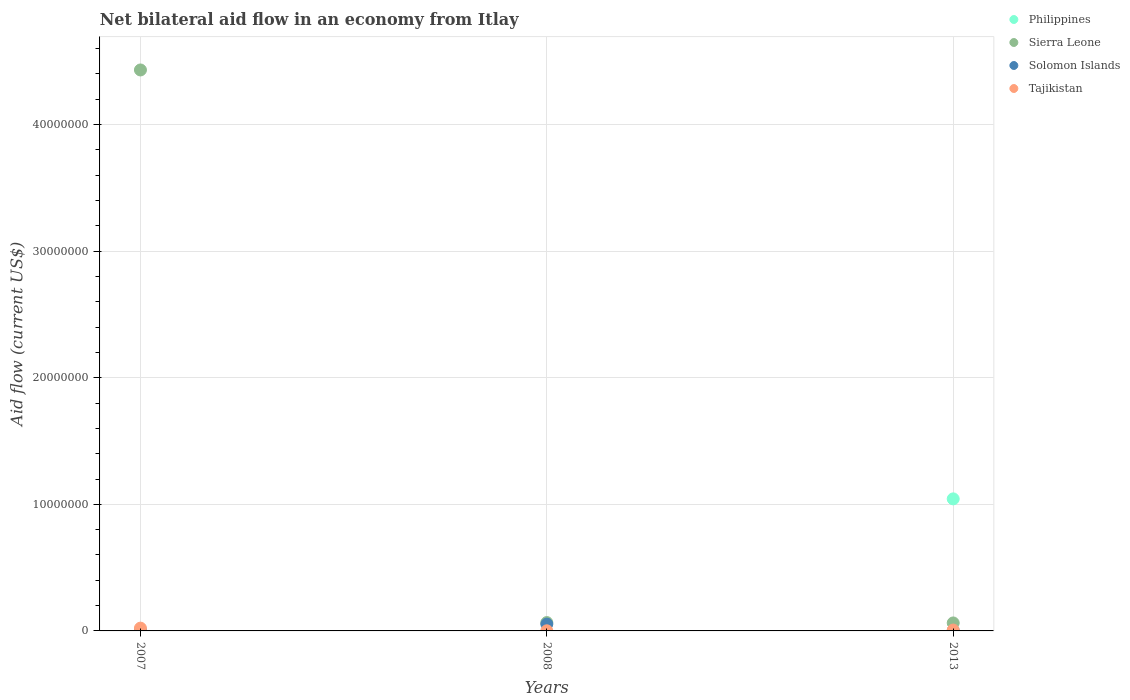How many different coloured dotlines are there?
Make the answer very short. 4. What is the net bilateral aid flow in Tajikistan in 2008?
Offer a very short reply. 10000. What is the total net bilateral aid flow in Philippines in the graph?
Your response must be concise. 1.04e+07. What is the difference between the net bilateral aid flow in Solomon Islands in 2008 and that in 2013?
Give a very brief answer. 5.20e+05. What is the difference between the net bilateral aid flow in Tajikistan in 2008 and the net bilateral aid flow in Sierra Leone in 2007?
Provide a succinct answer. -4.43e+07. What is the average net bilateral aid flow in Philippines per year?
Give a very brief answer. 3.48e+06. In the year 2007, what is the difference between the net bilateral aid flow in Sierra Leone and net bilateral aid flow in Tajikistan?
Provide a short and direct response. 4.41e+07. In how many years, is the net bilateral aid flow in Philippines greater than 34000000 US$?
Offer a very short reply. 0. What is the ratio of the net bilateral aid flow in Solomon Islands in 2007 to that in 2008?
Give a very brief answer. 0.09. Is the net bilateral aid flow in Tajikistan in 2007 less than that in 2013?
Your response must be concise. No. What is the difference between the highest and the lowest net bilateral aid flow in Solomon Islands?
Your answer should be very brief. 5.20e+05. In how many years, is the net bilateral aid flow in Solomon Islands greater than the average net bilateral aid flow in Solomon Islands taken over all years?
Provide a short and direct response. 1. Is it the case that in every year, the sum of the net bilateral aid flow in Philippines and net bilateral aid flow in Tajikistan  is greater than the net bilateral aid flow in Solomon Islands?
Ensure brevity in your answer.  No. Does the net bilateral aid flow in Tajikistan monotonically increase over the years?
Provide a succinct answer. No. Is the net bilateral aid flow in Sierra Leone strictly greater than the net bilateral aid flow in Philippines over the years?
Ensure brevity in your answer.  No. How many dotlines are there?
Your response must be concise. 4. What is the difference between two consecutive major ticks on the Y-axis?
Provide a succinct answer. 1.00e+07. Does the graph contain any zero values?
Offer a very short reply. Yes. How many legend labels are there?
Your answer should be very brief. 4. How are the legend labels stacked?
Ensure brevity in your answer.  Vertical. What is the title of the graph?
Provide a succinct answer. Net bilateral aid flow in an economy from Itlay. What is the label or title of the X-axis?
Offer a very short reply. Years. What is the Aid flow (current US$) in Philippines in 2007?
Your answer should be very brief. 0. What is the Aid flow (current US$) in Sierra Leone in 2007?
Keep it short and to the point. 4.43e+07. What is the Aid flow (current US$) of Solomon Islands in 2007?
Keep it short and to the point. 5.00e+04. What is the Aid flow (current US$) in Solomon Islands in 2008?
Make the answer very short. 5.40e+05. What is the Aid flow (current US$) of Tajikistan in 2008?
Offer a terse response. 10000. What is the Aid flow (current US$) of Philippines in 2013?
Your answer should be very brief. 1.04e+07. What is the Aid flow (current US$) of Sierra Leone in 2013?
Your answer should be very brief. 6.30e+05. What is the Aid flow (current US$) in Solomon Islands in 2013?
Your response must be concise. 2.00e+04. Across all years, what is the maximum Aid flow (current US$) of Philippines?
Your answer should be very brief. 1.04e+07. Across all years, what is the maximum Aid flow (current US$) of Sierra Leone?
Offer a terse response. 4.43e+07. Across all years, what is the maximum Aid flow (current US$) in Solomon Islands?
Provide a short and direct response. 5.40e+05. Across all years, what is the minimum Aid flow (current US$) of Philippines?
Ensure brevity in your answer.  0. Across all years, what is the minimum Aid flow (current US$) of Sierra Leone?
Ensure brevity in your answer.  6.30e+05. Across all years, what is the minimum Aid flow (current US$) in Solomon Islands?
Provide a succinct answer. 2.00e+04. What is the total Aid flow (current US$) in Philippines in the graph?
Your response must be concise. 1.04e+07. What is the total Aid flow (current US$) in Sierra Leone in the graph?
Your response must be concise. 4.56e+07. What is the total Aid flow (current US$) in Tajikistan in the graph?
Ensure brevity in your answer.  3.00e+05. What is the difference between the Aid flow (current US$) in Sierra Leone in 2007 and that in 2008?
Offer a terse response. 4.36e+07. What is the difference between the Aid flow (current US$) of Solomon Islands in 2007 and that in 2008?
Keep it short and to the point. -4.90e+05. What is the difference between the Aid flow (current US$) of Sierra Leone in 2007 and that in 2013?
Keep it short and to the point. 4.37e+07. What is the difference between the Aid flow (current US$) in Solomon Islands in 2007 and that in 2013?
Offer a very short reply. 3.00e+04. What is the difference between the Aid flow (current US$) in Sierra Leone in 2008 and that in 2013?
Ensure brevity in your answer.  3.00e+04. What is the difference between the Aid flow (current US$) in Solomon Islands in 2008 and that in 2013?
Provide a short and direct response. 5.20e+05. What is the difference between the Aid flow (current US$) of Tajikistan in 2008 and that in 2013?
Offer a very short reply. -6.00e+04. What is the difference between the Aid flow (current US$) of Sierra Leone in 2007 and the Aid flow (current US$) of Solomon Islands in 2008?
Provide a short and direct response. 4.38e+07. What is the difference between the Aid flow (current US$) in Sierra Leone in 2007 and the Aid flow (current US$) in Tajikistan in 2008?
Make the answer very short. 4.43e+07. What is the difference between the Aid flow (current US$) of Solomon Islands in 2007 and the Aid flow (current US$) of Tajikistan in 2008?
Offer a very short reply. 4.00e+04. What is the difference between the Aid flow (current US$) of Sierra Leone in 2007 and the Aid flow (current US$) of Solomon Islands in 2013?
Provide a short and direct response. 4.43e+07. What is the difference between the Aid flow (current US$) of Sierra Leone in 2007 and the Aid flow (current US$) of Tajikistan in 2013?
Ensure brevity in your answer.  4.42e+07. What is the difference between the Aid flow (current US$) of Solomon Islands in 2007 and the Aid flow (current US$) of Tajikistan in 2013?
Ensure brevity in your answer.  -2.00e+04. What is the difference between the Aid flow (current US$) in Sierra Leone in 2008 and the Aid flow (current US$) in Solomon Islands in 2013?
Make the answer very short. 6.40e+05. What is the difference between the Aid flow (current US$) of Sierra Leone in 2008 and the Aid flow (current US$) of Tajikistan in 2013?
Offer a terse response. 5.90e+05. What is the average Aid flow (current US$) of Philippines per year?
Give a very brief answer. 3.48e+06. What is the average Aid flow (current US$) of Sierra Leone per year?
Make the answer very short. 1.52e+07. What is the average Aid flow (current US$) of Solomon Islands per year?
Offer a terse response. 2.03e+05. In the year 2007, what is the difference between the Aid flow (current US$) in Sierra Leone and Aid flow (current US$) in Solomon Islands?
Keep it short and to the point. 4.43e+07. In the year 2007, what is the difference between the Aid flow (current US$) in Sierra Leone and Aid flow (current US$) in Tajikistan?
Provide a succinct answer. 4.41e+07. In the year 2007, what is the difference between the Aid flow (current US$) of Solomon Islands and Aid flow (current US$) of Tajikistan?
Your answer should be compact. -1.70e+05. In the year 2008, what is the difference between the Aid flow (current US$) in Sierra Leone and Aid flow (current US$) in Tajikistan?
Keep it short and to the point. 6.50e+05. In the year 2008, what is the difference between the Aid flow (current US$) in Solomon Islands and Aid flow (current US$) in Tajikistan?
Provide a short and direct response. 5.30e+05. In the year 2013, what is the difference between the Aid flow (current US$) of Philippines and Aid flow (current US$) of Sierra Leone?
Offer a very short reply. 9.80e+06. In the year 2013, what is the difference between the Aid flow (current US$) of Philippines and Aid flow (current US$) of Solomon Islands?
Offer a terse response. 1.04e+07. In the year 2013, what is the difference between the Aid flow (current US$) in Philippines and Aid flow (current US$) in Tajikistan?
Offer a terse response. 1.04e+07. In the year 2013, what is the difference between the Aid flow (current US$) in Sierra Leone and Aid flow (current US$) in Solomon Islands?
Offer a very short reply. 6.10e+05. In the year 2013, what is the difference between the Aid flow (current US$) of Sierra Leone and Aid flow (current US$) of Tajikistan?
Provide a short and direct response. 5.60e+05. What is the ratio of the Aid flow (current US$) in Sierra Leone in 2007 to that in 2008?
Keep it short and to the point. 67.14. What is the ratio of the Aid flow (current US$) of Solomon Islands in 2007 to that in 2008?
Provide a succinct answer. 0.09. What is the ratio of the Aid flow (current US$) of Sierra Leone in 2007 to that in 2013?
Provide a short and direct response. 70.33. What is the ratio of the Aid flow (current US$) of Tajikistan in 2007 to that in 2013?
Provide a succinct answer. 3.14. What is the ratio of the Aid flow (current US$) in Sierra Leone in 2008 to that in 2013?
Your response must be concise. 1.05. What is the ratio of the Aid flow (current US$) of Tajikistan in 2008 to that in 2013?
Offer a terse response. 0.14. What is the difference between the highest and the second highest Aid flow (current US$) in Sierra Leone?
Ensure brevity in your answer.  4.36e+07. What is the difference between the highest and the lowest Aid flow (current US$) in Philippines?
Offer a very short reply. 1.04e+07. What is the difference between the highest and the lowest Aid flow (current US$) in Sierra Leone?
Offer a very short reply. 4.37e+07. What is the difference between the highest and the lowest Aid flow (current US$) in Solomon Islands?
Your answer should be very brief. 5.20e+05. 